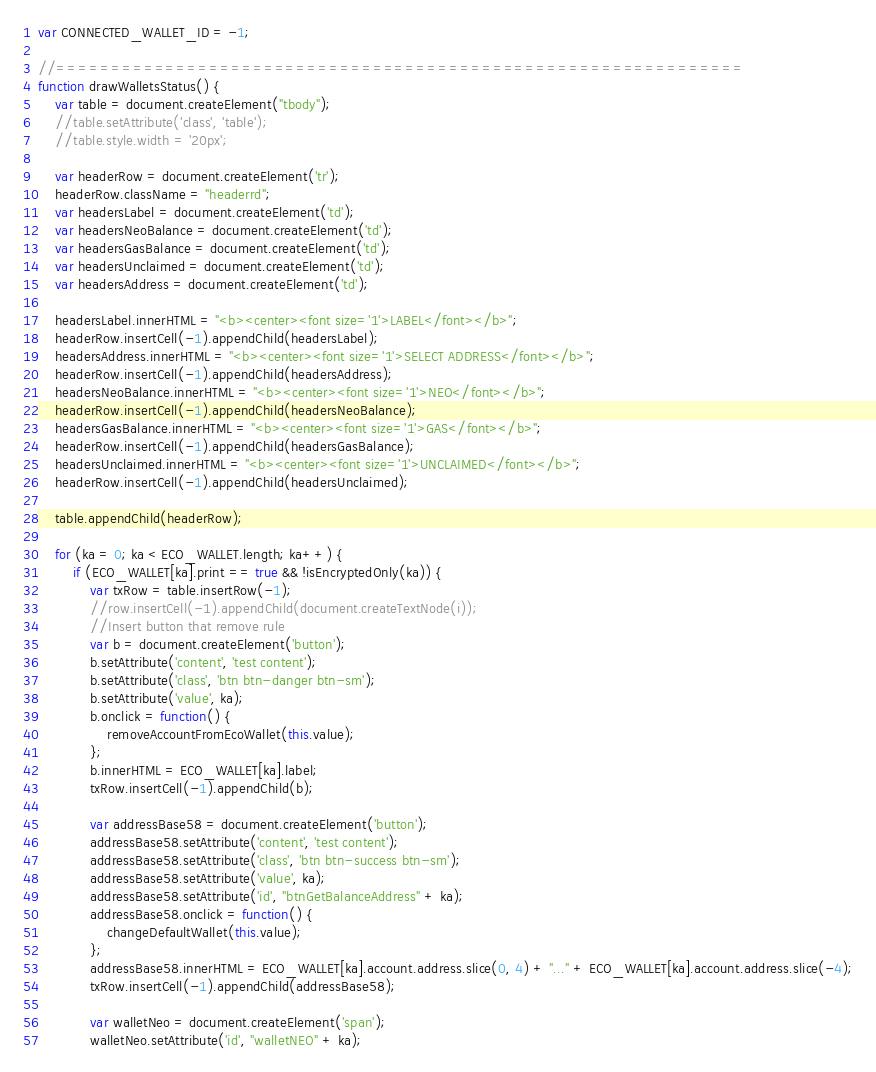Convert code to text. <code><loc_0><loc_0><loc_500><loc_500><_JavaScript_>var CONNECTED_WALLET_ID = -1;

//===============================================================
function drawWalletsStatus() {
    var table = document.createElement("tbody");
    //table.setAttribute('class', 'table');
    //table.style.width = '20px';

    var headerRow = document.createElement('tr');
    headerRow.className = "headerrd";
    var headersLabel = document.createElement('td');
    var headersNeoBalance = document.createElement('td');
    var headersGasBalance = document.createElement('td');
    var headersUnclaimed = document.createElement('td');
    var headersAddress = document.createElement('td');

    headersLabel.innerHTML = "<b><center><font size='1'>LABEL</font></b>";
    headerRow.insertCell(-1).appendChild(headersLabel);
    headersAddress.innerHTML = "<b><center><font size='1'>SELECT ADDRESS</font></b>";
    headerRow.insertCell(-1).appendChild(headersAddress);
    headersNeoBalance.innerHTML = "<b><center><font size='1'>NEO</font></b>";
    headerRow.insertCell(-1).appendChild(headersNeoBalance);
    headersGasBalance.innerHTML = "<b><center><font size='1'>GAS</font></b>";
    headerRow.insertCell(-1).appendChild(headersGasBalance);
    headersUnclaimed.innerHTML = "<b><center><font size='1'>UNCLAIMED</font></b>";
    headerRow.insertCell(-1).appendChild(headersUnclaimed);

    table.appendChild(headerRow);

    for (ka = 0; ka < ECO_WALLET.length; ka++) {
        if (ECO_WALLET[ka].print == true && !isEncryptedOnly(ka)) {
            var txRow = table.insertRow(-1);
            //row.insertCell(-1).appendChild(document.createTextNode(i));
            //Insert button that remove rule
            var b = document.createElement('button');
            b.setAttribute('content', 'test content');
            b.setAttribute('class', 'btn btn-danger btn-sm');
            b.setAttribute('value', ka);
            b.onclick = function() {
                removeAccountFromEcoWallet(this.value);
            };
            b.innerHTML = ECO_WALLET[ka].label;
            txRow.insertCell(-1).appendChild(b);

            var addressBase58 = document.createElement('button');
            addressBase58.setAttribute('content', 'test content');
            addressBase58.setAttribute('class', 'btn btn-success btn-sm');
            addressBase58.setAttribute('value', ka);
            addressBase58.setAttribute('id', "btnGetBalanceAddress" + ka);
            addressBase58.onclick = function() {
                changeDefaultWallet(this.value);
            };
            addressBase58.innerHTML = ECO_WALLET[ka].account.address.slice(0, 4) + "..." + ECO_WALLET[ka].account.address.slice(-4);
            txRow.insertCell(-1).appendChild(addressBase58);

            var walletNeo = document.createElement('span');
            walletNeo.setAttribute('id', "walletNEO" + ka);</code> 